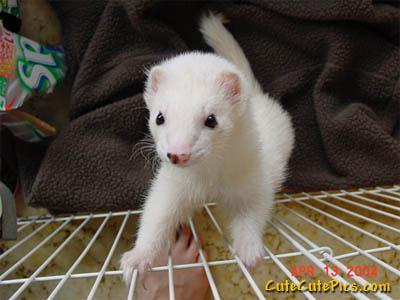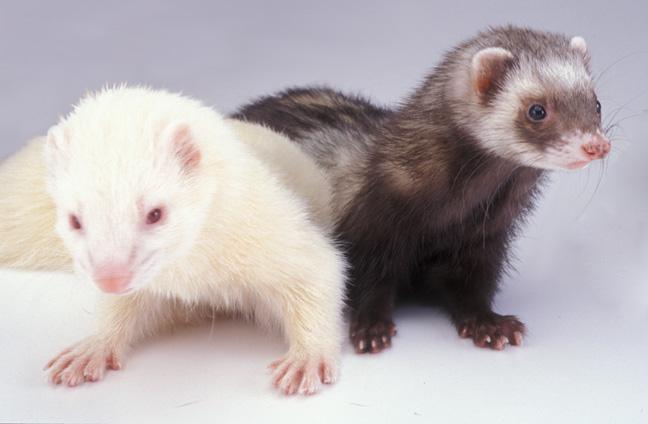The first image is the image on the left, the second image is the image on the right. For the images displayed, is the sentence "There is exactly two ferrets." factually correct? Answer yes or no. No. 